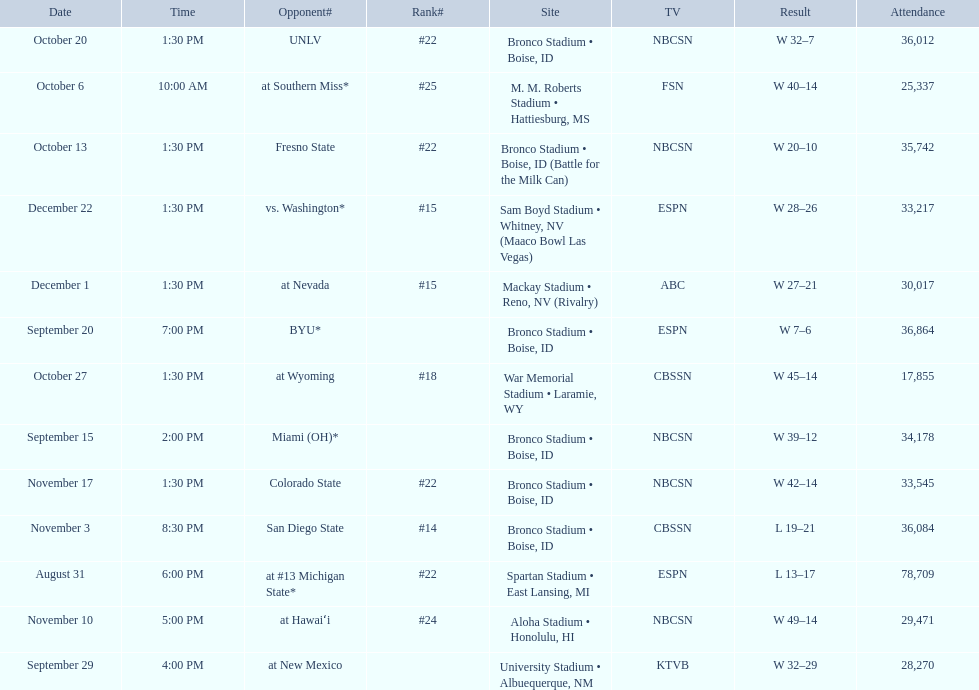Who were all the opponents for boise state? At #13 michigan state*, miami (oh)*, byu*, at new mexico, at southern miss*, fresno state, unlv, at wyoming, san diego state, at hawaiʻi, colorado state, at nevada, vs. washington*. Which opponents were ranked? At #13 michigan state*, #22, at southern miss*, #25, fresno state, #22, unlv, #22, at wyoming, #18, san diego state, #14. Which opponent had the highest rank? San Diego State. 